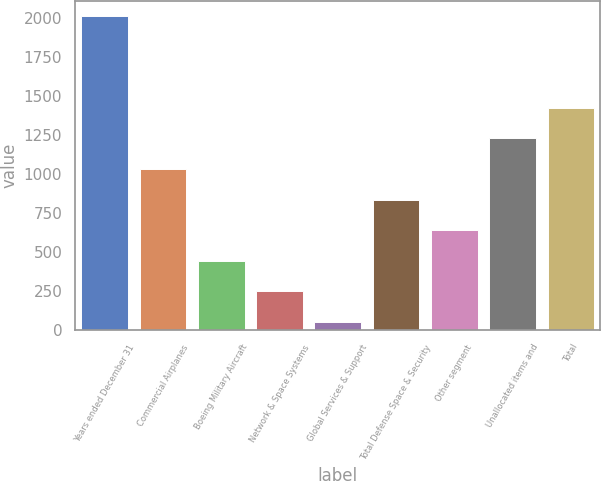<chart> <loc_0><loc_0><loc_500><loc_500><bar_chart><fcel>Years ended December 31<fcel>Commercial Airplanes<fcel>Boeing Military Aircraft<fcel>Network & Space Systems<fcel>Global Services & Support<fcel>Total Defense Space & Security<fcel>Other segment<fcel>Unallocated items and<fcel>Total<nl><fcel>2010<fcel>1030.5<fcel>442.8<fcel>246.9<fcel>51<fcel>834.6<fcel>638.7<fcel>1226.4<fcel>1422.3<nl></chart> 